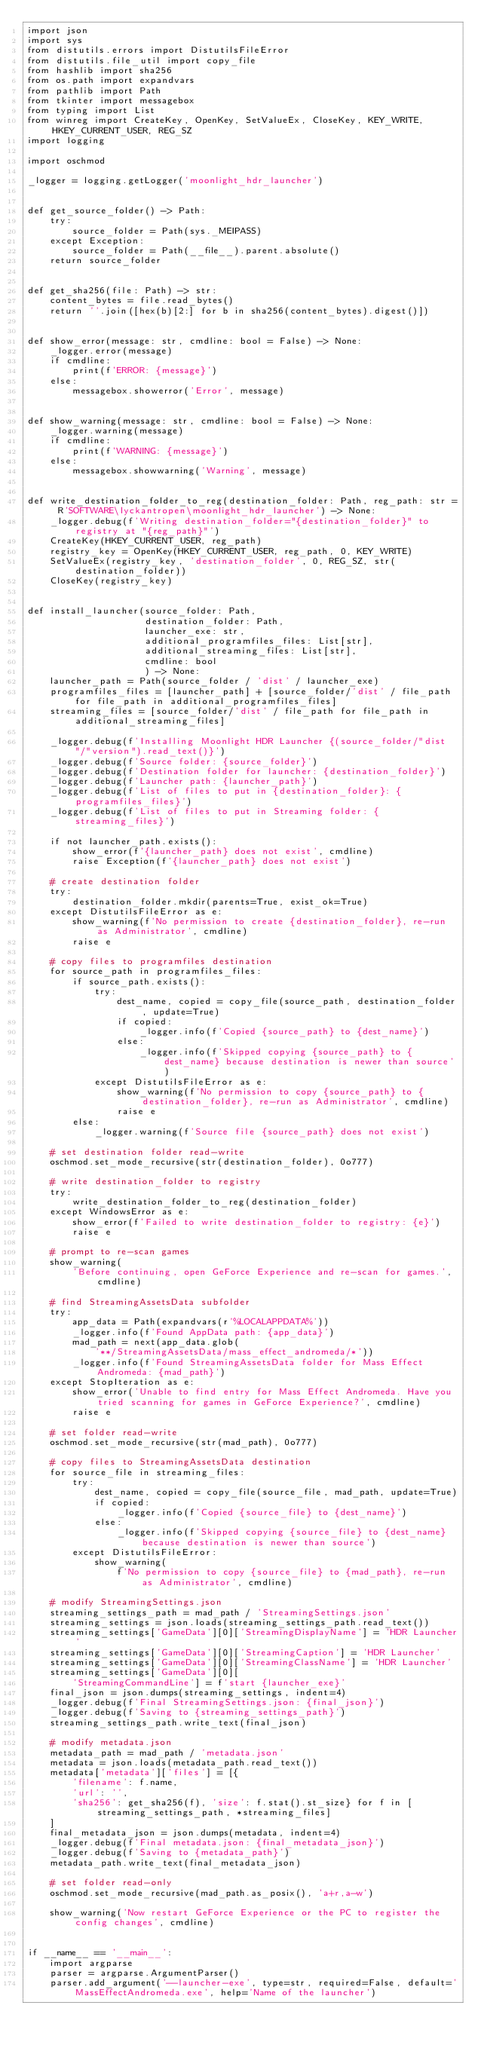<code> <loc_0><loc_0><loc_500><loc_500><_Python_>import json
import sys
from distutils.errors import DistutilsFileError
from distutils.file_util import copy_file
from hashlib import sha256
from os.path import expandvars
from pathlib import Path
from tkinter import messagebox
from typing import List
from winreg import CreateKey, OpenKey, SetValueEx, CloseKey, KEY_WRITE, HKEY_CURRENT_USER, REG_SZ
import logging

import oschmod

_logger = logging.getLogger('moonlight_hdr_launcher')


def get_source_folder() -> Path:
    try:
        source_folder = Path(sys._MEIPASS)
    except Exception:
        source_folder = Path(__file__).parent.absolute()
    return source_folder


def get_sha256(file: Path) -> str:
    content_bytes = file.read_bytes()
    return ''.join([hex(b)[2:] for b in sha256(content_bytes).digest()])


def show_error(message: str, cmdline: bool = False) -> None:
    _logger.error(message)
    if cmdline:
        print(f'ERROR: {message}')
    else:
        messagebox.showerror('Error', message)


def show_warning(message: str, cmdline: bool = False) -> None:
    _logger.warning(message)
    if cmdline:
        print(f'WARNING: {message}')
    else:
        messagebox.showwarning('Warning', message)


def write_destination_folder_to_reg(destination_folder: Path, reg_path: str = R'SOFTWARE\lyckantropen\moonlight_hdr_launcher') -> None:
    _logger.debug(f'Writing destination_folder="{destination_folder}" to registry at "{reg_path}"')
    CreateKey(HKEY_CURRENT_USER, reg_path)
    registry_key = OpenKey(HKEY_CURRENT_USER, reg_path, 0, KEY_WRITE)
    SetValueEx(registry_key, 'destination_folder', 0, REG_SZ, str(destination_folder))
    CloseKey(registry_key)


def install_launcher(source_folder: Path,
                     destination_folder: Path,
                     launcher_exe: str,
                     additional_programfiles_files: List[str],
                     additional_streaming_files: List[str],
                     cmdline: bool
                     ) -> None:
    launcher_path = Path(source_folder / 'dist' / launcher_exe)
    programfiles_files = [launcher_path] + [source_folder/'dist' / file_path for file_path in additional_programfiles_files]
    streaming_files = [source_folder/'dist' / file_path for file_path in additional_streaming_files]

    _logger.debug(f'Installing Moonlight HDR Launcher {(source_folder/"dist"/"version").read_text()}')
    _logger.debug(f'Source folder: {source_folder}')
    _logger.debug(f'Destination folder for launcher: {destination_folder}')
    _logger.debug(f'Launcher path: {launcher_path}')
    _logger.debug(f'List of files to put in {destination_folder}: {programfiles_files}')
    _logger.debug(f'List of files to put in Streaming folder: {streaming_files}')

    if not launcher_path.exists():
        show_error(f'{launcher_path} does not exist', cmdline)
        raise Exception(f'{launcher_path} does not exist')

    # create destination folder
    try:
        destination_folder.mkdir(parents=True, exist_ok=True)
    except DistutilsFileError as e:
        show_warning(f'No permission to create {destination_folder}, re-run as Administrator', cmdline)
        raise e

    # copy files to programfiles destination
    for source_path in programfiles_files:
        if source_path.exists():
            try:
                dest_name, copied = copy_file(source_path, destination_folder, update=True)
                if copied:
                    _logger.info(f'Copied {source_path} to {dest_name}')
                else:
                    _logger.info(f'Skipped copying {source_path} to {dest_name} because destination is newer than source')
            except DistutilsFileError as e:
                show_warning(f'No permission to copy {source_path} to {destination_folder}, re-run as Administrator', cmdline)
                raise e
        else:
            _logger.warning(f'Source file {source_path} does not exist')

    # set destination folder read-write
    oschmod.set_mode_recursive(str(destination_folder), 0o777)

    # write destination_folder to registry
    try:
        write_destination_folder_to_reg(destination_folder)
    except WindowsError as e:
        show_error(f'Failed to write destination_folder to registry: {e}')
        raise e

    # prompt to re-scan games
    show_warning(
        'Before continuing, open GeForce Experience and re-scan for games.', cmdline)

    # find StreamingAssetsData subfolder
    try:
        app_data = Path(expandvars(r'%LOCALAPPDATA%'))
        _logger.info(f'Found AppData path: {app_data}')
        mad_path = next(app_data.glob(
            '**/StreamingAssetsData/mass_effect_andromeda/*'))
        _logger.info(f'Found StreamingAssetsData folder for Mass Effect Andromeda: {mad_path}')
    except StopIteration as e:
        show_error('Unable to find entry for Mass Effect Andromeda. Have you tried scanning for games in GeForce Experience?', cmdline)
        raise e

    # set folder read-write
    oschmod.set_mode_recursive(str(mad_path), 0o777)

    # copy files to StreamingAssetsData destination
    for source_file in streaming_files:
        try:
            dest_name, copied = copy_file(source_file, mad_path, update=True)
            if copied:
                _logger.info(f'Copied {source_file} to {dest_name}')
            else:
                _logger.info(f'Skipped copying {source_file} to {dest_name} because destination is newer than source')
        except DistutilsFileError:
            show_warning(
                f'No permission to copy {source_file} to {mad_path}, re-run as Administrator', cmdline)

    # modify StreamingSettings.json
    streaming_settings_path = mad_path / 'StreamingSettings.json'
    streaming_settings = json.loads(streaming_settings_path.read_text())
    streaming_settings['GameData'][0]['StreamingDisplayName'] = 'HDR Launcher'
    streaming_settings['GameData'][0]['StreamingCaption'] = 'HDR Launcher'
    streaming_settings['GameData'][0]['StreamingClassName'] = 'HDR Launcher'
    streaming_settings['GameData'][0][
        'StreamingCommandLine'] = f'start {launcher_exe}'
    final_json = json.dumps(streaming_settings, indent=4)
    _logger.debug(f'Final StreamingSettings.json: {final_json}')
    _logger.debug(f'Saving to {streaming_settings_path}')
    streaming_settings_path.write_text(final_json)

    # modify metadata.json
    metadata_path = mad_path / 'metadata.json'
    metadata = json.loads(metadata_path.read_text())
    metadata['metadata']['files'] = [{
        'filename': f.name,
        'url': '',
        'sha256': get_sha256(f), 'size': f.stat().st_size} for f in [streaming_settings_path, *streaming_files]
    ]
    final_metadata_json = json.dumps(metadata, indent=4)
    _logger.debug(f'Final metadata.json: {final_metadata_json}')
    _logger.debug(f'Saving to {metadata_path}')
    metadata_path.write_text(final_metadata_json)

    # set folder read-only
    oschmod.set_mode_recursive(mad_path.as_posix(), 'a+r,a-w')

    show_warning('Now restart GeForce Experience or the PC to register the config changes', cmdline)


if __name__ == '__main__':
    import argparse
    parser = argparse.ArgumentParser()
    parser.add_argument('--launcher-exe', type=str, required=False, default='MassEffectAndromeda.exe', help='Name of the launcher')</code> 